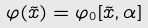<formula> <loc_0><loc_0><loc_500><loc_500>\varphi ( \tilde { x } ) = \varphi _ { 0 } [ \tilde { x } , \alpha ]</formula> 